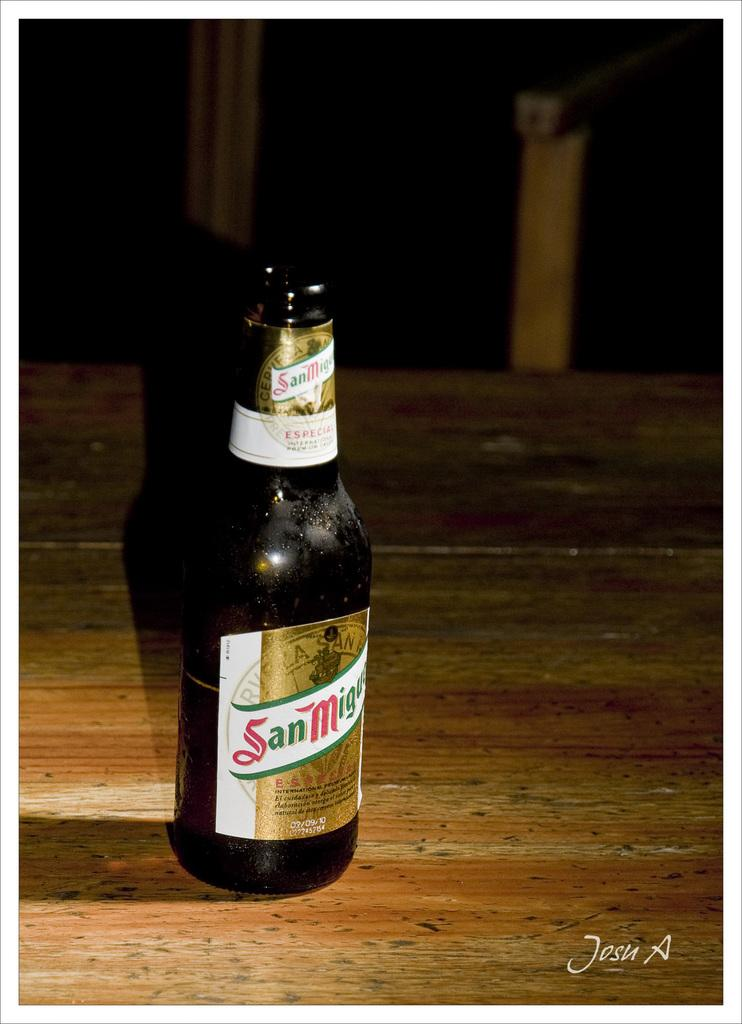<image>
Share a concise interpretation of the image provided. An opened bottle of San Miguel sits on a wooden table. 